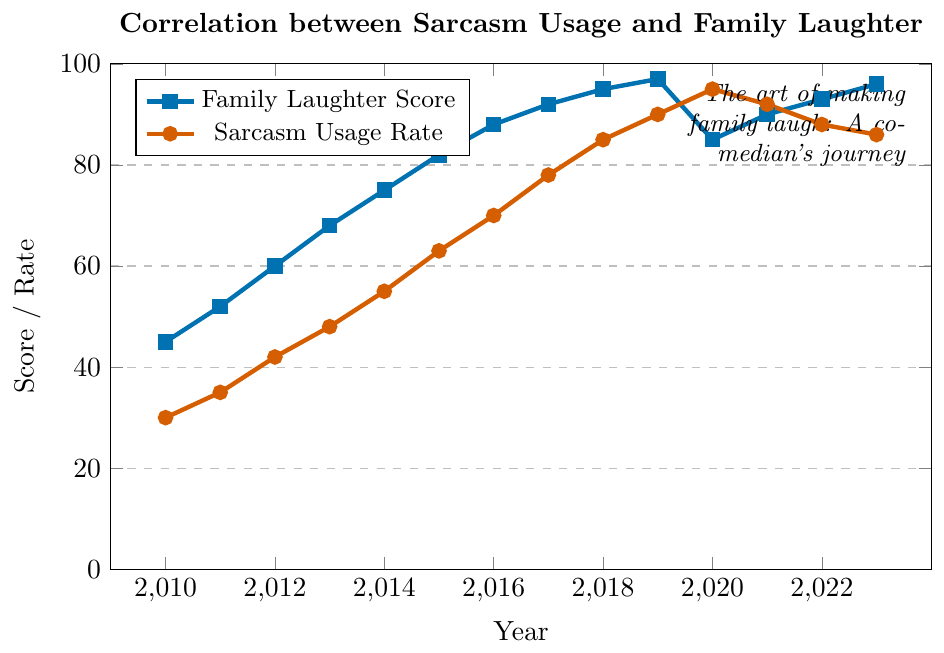What year had the highest Family Laughter Score? To find the highest Family Laughter Score, look for the highest point on the blue line in the graph. The highest value for Family Laughter Score is 96, which occurs in 2023.
Answer: 2023 How did the Sarcasm Usage Rate change from 2010 to 2020? Compare the Sarcasm Usage Rate in 2010 to that in 2020. In 2010, the rate was 30, and in 2020, it was 95, showing an increasing trend.
Answer: Increased What trend can you observe about the Family Laughter Score from 2010 to 2023? Examine the blue line representing the Family Laughter Score. From 2010 to 2019, it generally increases, slightly dips in 2020, then increases again in subsequent years till 2023.
Answer: Generally increasing with minor dips By how much did the Family Laughter Score increase from 2010 to 2019? Subtract the Family Laughter Score in 2010 (45) from that in 2019 (97). So, 97 - 45 = 52.
Answer: 52 What is the correlation between the Sarcasm Usage Rate and the Family Laughter Score in 2018? The values for 2018 are taken from the plot: Sarcasm Usage Rate is 85 and Family Laughter Score is 95. Both are near their peak values, indicating a strong positive correlation.
Answer: Strong positive correlation In what years did the Family Laughter Score decrease compared to the previous year? Check the blue line for downward slopes. The Family Laughter Score decreased from 2019 to 2020, and from 2020 to 2021.
Answer: 2020, 2021 Which had a greater increase rate from 2015 to 2017: Family Laughter Score or Sarcasm Usage Rate? Calculate the increase for Family Laughter Score and Sarcasm Usage Rate from 2015 to 2017. Family Laughter Score: 92 - 82 = 10. Sarcasm Usage Rate: 78 - 63 = 15. Compare the two: 10 < 15, so Sarcasm Usage Rate increased more.
Answer: Sarcasm Usage Rate What was the difference between the Family Laughter Score and Sarcasm Usage Rate in 2023? Subtract the Sarcasm Usage Rate in 2023 (86) from the Family Laughter Score in 2023 (96). So, 96 - 86 = 10.
Answer: 10 How does the graph illustrate the relationship between sarcasm and family laughter over time? The graph shows both lines increasing together until 2019, with the Sarcasm Usage Rate surpassing Family Laughter Score in 2020, indicating a point where too much sarcasm may have reduced laughter, and then converging again in subsequent years.
Answer: Positive correlation with a critical point 